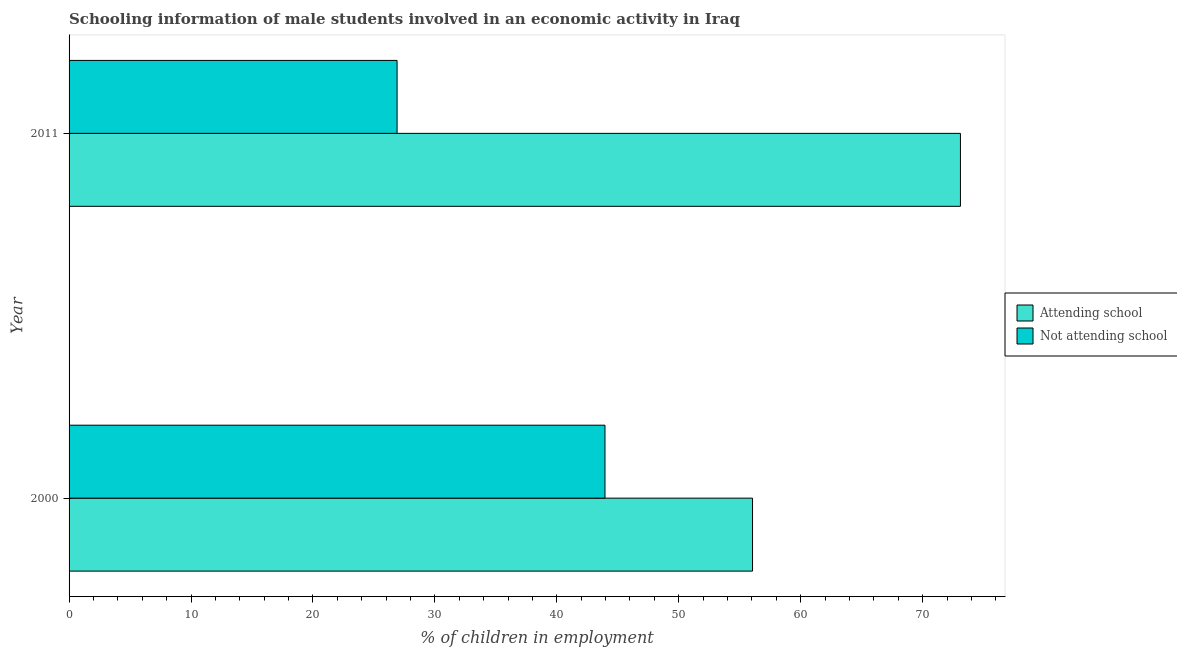How many groups of bars are there?
Your response must be concise. 2. How many bars are there on the 1st tick from the top?
Ensure brevity in your answer.  2. What is the label of the 2nd group of bars from the top?
Your answer should be compact. 2000. What is the percentage of employed males who are attending school in 2011?
Your answer should be compact. 73.1. Across all years, what is the maximum percentage of employed males who are not attending school?
Give a very brief answer. 43.95. Across all years, what is the minimum percentage of employed males who are not attending school?
Your answer should be very brief. 26.9. In which year was the percentage of employed males who are not attending school maximum?
Provide a short and direct response. 2000. What is the total percentage of employed males who are not attending school in the graph?
Provide a succinct answer. 70.85. What is the difference between the percentage of employed males who are not attending school in 2000 and that in 2011?
Make the answer very short. 17.05. What is the difference between the percentage of employed males who are attending school in 2000 and the percentage of employed males who are not attending school in 2011?
Your answer should be compact. 29.15. What is the average percentage of employed males who are not attending school per year?
Provide a short and direct response. 35.42. In the year 2000, what is the difference between the percentage of employed males who are not attending school and percentage of employed males who are attending school?
Keep it short and to the point. -12.1. What is the ratio of the percentage of employed males who are attending school in 2000 to that in 2011?
Make the answer very short. 0.77. Is the difference between the percentage of employed males who are attending school in 2000 and 2011 greater than the difference between the percentage of employed males who are not attending school in 2000 and 2011?
Your answer should be very brief. No. What does the 1st bar from the top in 2011 represents?
Provide a short and direct response. Not attending school. What does the 1st bar from the bottom in 2000 represents?
Your answer should be very brief. Attending school. How many bars are there?
Ensure brevity in your answer.  4. How many years are there in the graph?
Keep it short and to the point. 2. What is the difference between two consecutive major ticks on the X-axis?
Offer a terse response. 10. How many legend labels are there?
Offer a very short reply. 2. How are the legend labels stacked?
Offer a very short reply. Vertical. What is the title of the graph?
Give a very brief answer. Schooling information of male students involved in an economic activity in Iraq. What is the label or title of the X-axis?
Keep it short and to the point. % of children in employment. What is the % of children in employment of Attending school in 2000?
Keep it short and to the point. 56.05. What is the % of children in employment of Not attending school in 2000?
Provide a succinct answer. 43.95. What is the % of children in employment in Attending school in 2011?
Your answer should be very brief. 73.1. What is the % of children in employment of Not attending school in 2011?
Keep it short and to the point. 26.9. Across all years, what is the maximum % of children in employment of Attending school?
Give a very brief answer. 73.1. Across all years, what is the maximum % of children in employment in Not attending school?
Offer a very short reply. 43.95. Across all years, what is the minimum % of children in employment of Attending school?
Keep it short and to the point. 56.05. Across all years, what is the minimum % of children in employment of Not attending school?
Your response must be concise. 26.9. What is the total % of children in employment in Attending school in the graph?
Provide a short and direct response. 129.15. What is the total % of children in employment of Not attending school in the graph?
Offer a terse response. 70.85. What is the difference between the % of children in employment of Attending school in 2000 and that in 2011?
Offer a very short reply. -17.05. What is the difference between the % of children in employment in Not attending school in 2000 and that in 2011?
Offer a very short reply. 17.05. What is the difference between the % of children in employment of Attending school in 2000 and the % of children in employment of Not attending school in 2011?
Your answer should be very brief. 29.15. What is the average % of children in employment of Attending school per year?
Offer a very short reply. 64.58. What is the average % of children in employment in Not attending school per year?
Make the answer very short. 35.42. In the year 2000, what is the difference between the % of children in employment of Attending school and % of children in employment of Not attending school?
Offer a very short reply. 12.1. In the year 2011, what is the difference between the % of children in employment in Attending school and % of children in employment in Not attending school?
Make the answer very short. 46.2. What is the ratio of the % of children in employment in Attending school in 2000 to that in 2011?
Your response must be concise. 0.77. What is the ratio of the % of children in employment of Not attending school in 2000 to that in 2011?
Ensure brevity in your answer.  1.63. What is the difference between the highest and the second highest % of children in employment in Attending school?
Offer a very short reply. 17.05. What is the difference between the highest and the second highest % of children in employment in Not attending school?
Offer a very short reply. 17.05. What is the difference between the highest and the lowest % of children in employment of Attending school?
Your response must be concise. 17.05. What is the difference between the highest and the lowest % of children in employment in Not attending school?
Keep it short and to the point. 17.05. 